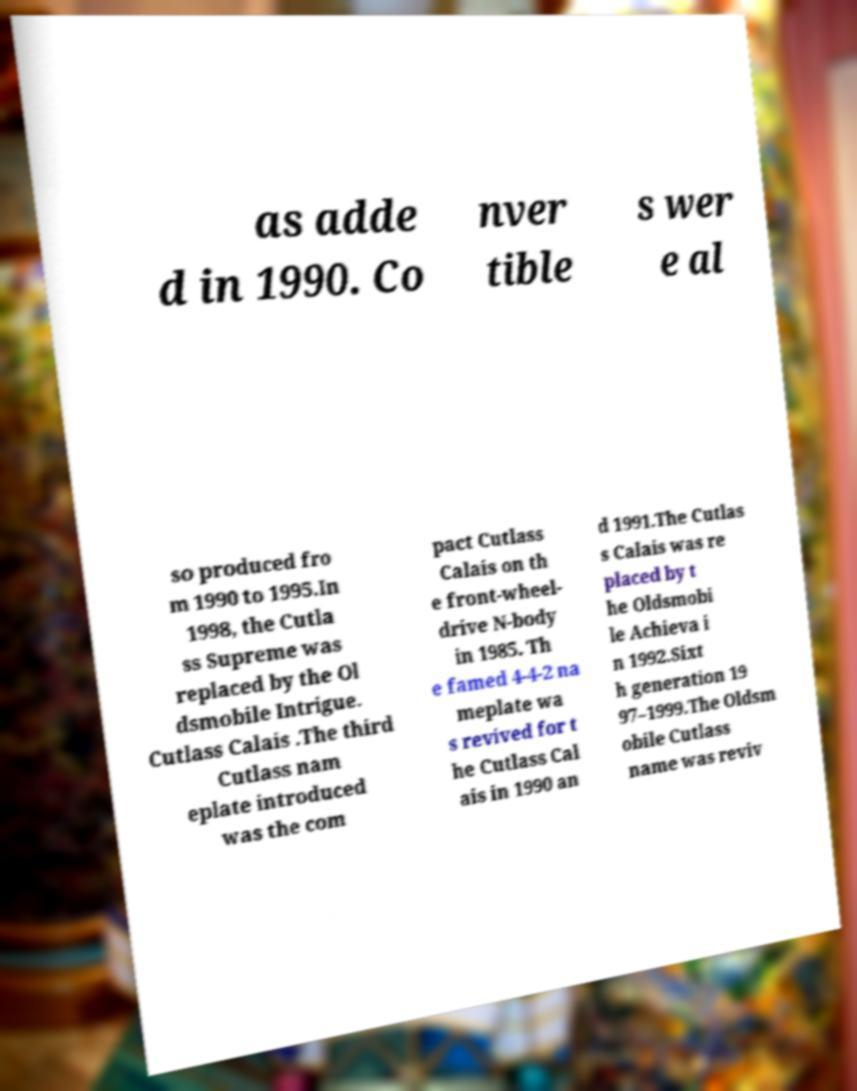Could you extract and type out the text from this image? as adde d in 1990. Co nver tible s wer e al so produced fro m 1990 to 1995.In 1998, the Cutla ss Supreme was replaced by the Ol dsmobile Intrigue. Cutlass Calais .The third Cutlass nam eplate introduced was the com pact Cutlass Calais on th e front-wheel- drive N-body in 1985. Th e famed 4-4-2 na meplate wa s revived for t he Cutlass Cal ais in 1990 an d 1991.The Cutlas s Calais was re placed by t he Oldsmobi le Achieva i n 1992.Sixt h generation 19 97–1999.The Oldsm obile Cutlass name was reviv 